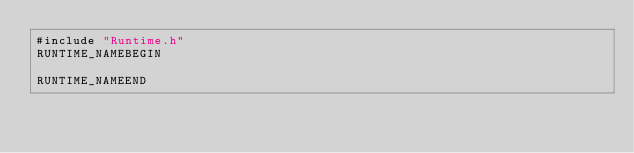<code> <loc_0><loc_0><loc_500><loc_500><_Cuda_>#include "Runtime.h"
RUNTIME_NAMEBEGIN

RUNTIME_NAMEEND
</code> 